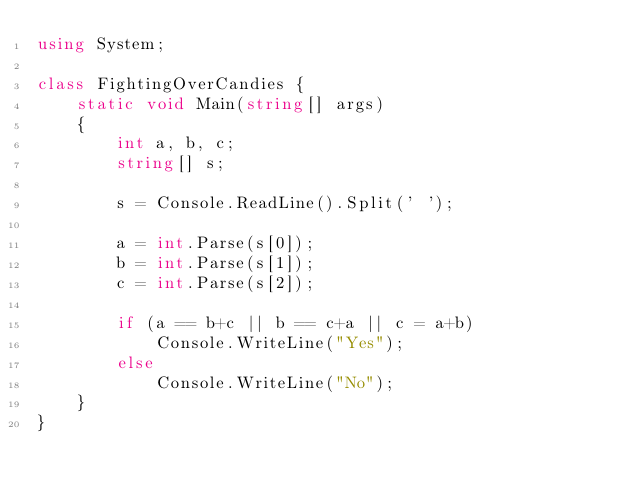Convert code to text. <code><loc_0><loc_0><loc_500><loc_500><_C#_>using System;

class FightingOverCandies {
    static void Main(string[] args)
    {
        int a, b, c;
        string[] s;

        s = Console.ReadLine().Split(' ');

        a = int.Parse(s[0]);
        b = int.Parse(s[1]);
        c = int.Parse(s[2]);

        if (a == b+c || b == c+a || c = a+b)
            Console.WriteLine("Yes");
        else
            Console.WriteLine("No");
    }
}</code> 